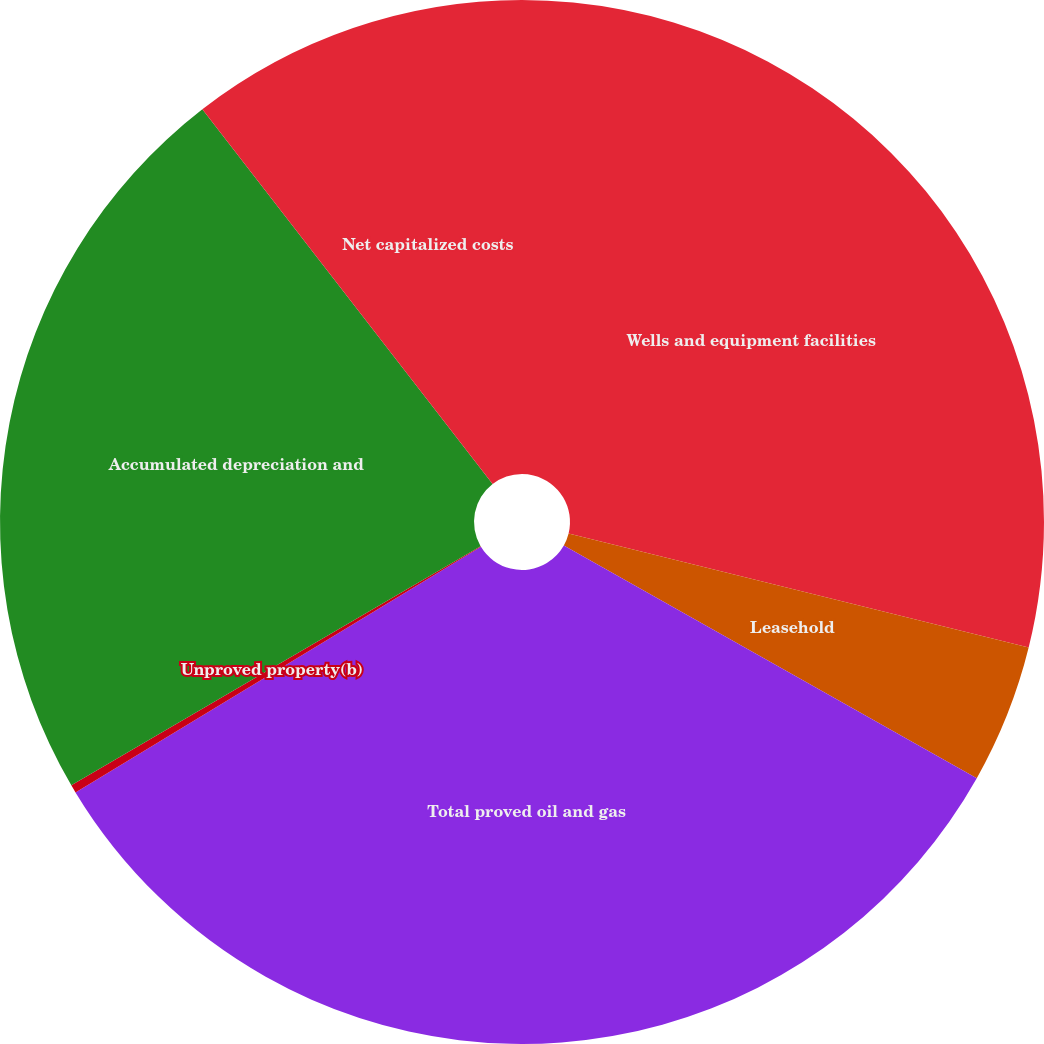<chart> <loc_0><loc_0><loc_500><loc_500><pie_chart><fcel>Wells and equipment facilities<fcel>Leasehold<fcel>Total proved oil and gas<fcel>Unproved property(b)<fcel>Accumulated depreciation and<fcel>Net capitalized costs<nl><fcel>28.87%<fcel>4.3%<fcel>33.17%<fcel>0.25%<fcel>22.93%<fcel>10.49%<nl></chart> 